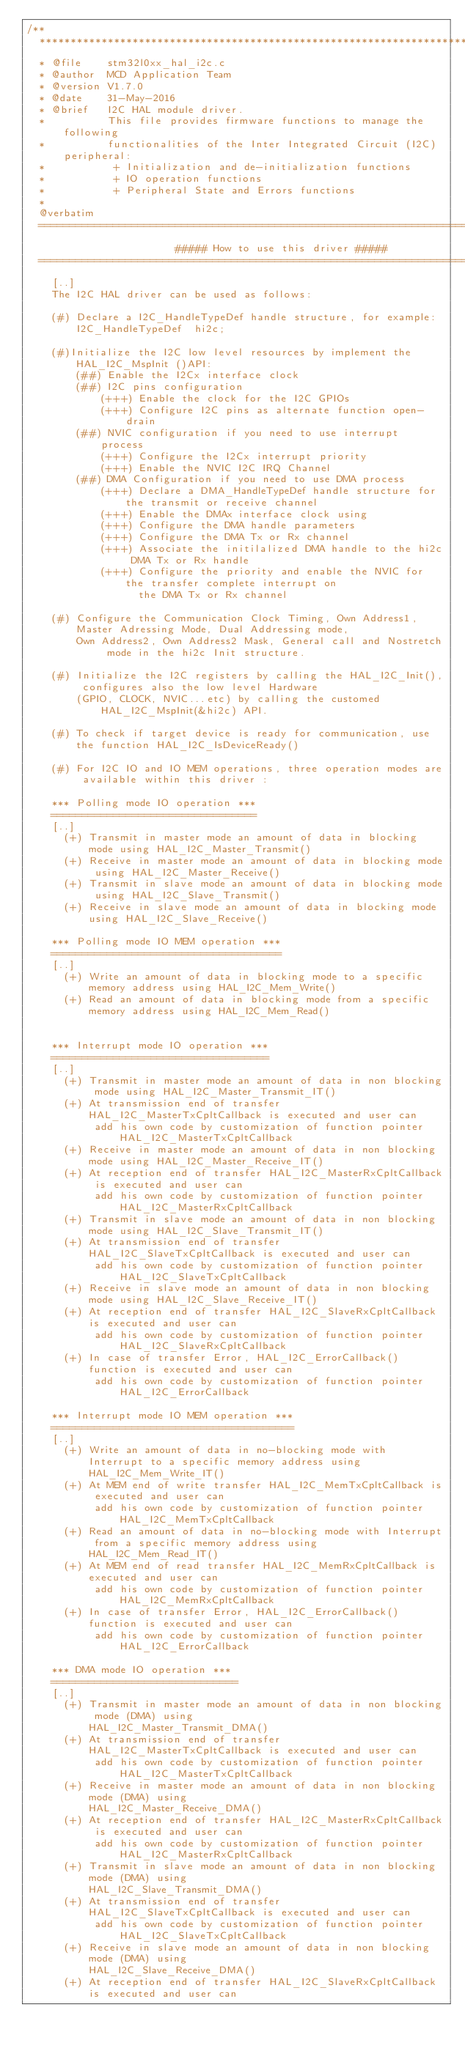<code> <loc_0><loc_0><loc_500><loc_500><_C_>/**
  ******************************************************************************
  * @file    stm32l0xx_hal_i2c.c
  * @author  MCD Application Team
  * @version V1.7.0
  * @date    31-May-2016
  * @brief   I2C HAL module driver.
  *          This file provides firmware functions to manage the following 
  *          functionalities of the Inter Integrated Circuit (I2C) peripheral:
  *           + Initialization and de-initialization functions
  *           + IO operation functions
  *           + Peripheral State and Errors functions
  *         
  @verbatim
  ==============================================================================
                        ##### How to use this driver #####
  ==============================================================================
    [..]
    The I2C HAL driver can be used as follows:
    
    (#) Declare a I2C_HandleTypeDef handle structure, for example:
        I2C_HandleTypeDef  hi2c; 

    (#)Initialize the I2C low level resources by implement the HAL_I2C_MspInit ()API:
        (##) Enable the I2Cx interface clock
        (##) I2C pins configuration
            (+++) Enable the clock for the I2C GPIOs
            (+++) Configure I2C pins as alternate function open-drain
        (##) NVIC configuration if you need to use interrupt process
            (+++) Configure the I2Cx interrupt priority
            (+++) Enable the NVIC I2C IRQ Channel
        (##) DMA Configuration if you need to use DMA process
            (+++) Declare a DMA_HandleTypeDef handle structure for the transmit or receive channel
            (+++) Enable the DMAx interface clock using
            (+++) Configure the DMA handle parameters
            (+++) Configure the DMA Tx or Rx channel
            (+++) Associate the initilalized DMA handle to the hi2c DMA Tx or Rx handle
            (+++) Configure the priority and enable the NVIC for the transfer complete interrupt on 
                  the DMA Tx or Rx channel

    (#) Configure the Communication Clock Timing, Own Address1, Master Adressing Mode, Dual Addressing mode,
        Own Address2, Own Address2 Mask, General call and Nostretch mode in the hi2c Init structure.

    (#) Initialize the I2C registers by calling the HAL_I2C_Init(), configures also the low level Hardware 
        (GPIO, CLOCK, NVIC...etc) by calling the customed HAL_I2C_MspInit(&hi2c) API.

    (#) To check if target device is ready for communication, use the function HAL_I2C_IsDeviceReady()

    (#) For I2C IO and IO MEM operations, three operation modes are available within this driver :

    *** Polling mode IO operation ***
    =================================
    [..]
      (+) Transmit in master mode an amount of data in blocking mode using HAL_I2C_Master_Transmit()
      (+) Receive in master mode an amount of data in blocking mode using HAL_I2C_Master_Receive()
      (+) Transmit in slave mode an amount of data in blocking mode using HAL_I2C_Slave_Transmit()
      (+) Receive in slave mode an amount of data in blocking mode using HAL_I2C_Slave_Receive()

    *** Polling mode IO MEM operation ***
    =====================================
    [..]
      (+) Write an amount of data in blocking mode to a specific memory address using HAL_I2C_Mem_Write()
      (+) Read an amount of data in blocking mode from a specific memory address using HAL_I2C_Mem_Read()


    *** Interrupt mode IO operation ***
    ===================================
    [..]
      (+) Transmit in master mode an amount of data in non blocking mode using HAL_I2C_Master_Transmit_IT()
      (+) At transmission end of transfer HAL_I2C_MasterTxCpltCallback is executed and user can
           add his own code by customization of function pointer HAL_I2C_MasterTxCpltCallback
      (+) Receive in master mode an amount of data in non blocking mode using HAL_I2C_Master_Receive_IT()
      (+) At reception end of transfer HAL_I2C_MasterRxCpltCallback is executed and user can
           add his own code by customization of function pointer HAL_I2C_MasterRxCpltCallback
      (+) Transmit in slave mode an amount of data in non blocking mode using HAL_I2C_Slave_Transmit_IT()
      (+) At transmission end of transfer HAL_I2C_SlaveTxCpltCallback is executed and user can
           add his own code by customization of function pointer HAL_I2C_SlaveTxCpltCallback
      (+) Receive in slave mode an amount of data in non blocking mode using HAL_I2C_Slave_Receive_IT()
      (+) At reception end of transfer HAL_I2C_SlaveRxCpltCallback is executed and user can
           add his own code by customization of function pointer HAL_I2C_SlaveRxCpltCallback
      (+) In case of transfer Error, HAL_I2C_ErrorCallback() function is executed and user can
           add his own code by customization of function pointer HAL_I2C_ErrorCallback

    *** Interrupt mode IO MEM operation ***
    =======================================
    [..]
      (+) Write an amount of data in no-blocking mode with Interrupt to a specific memory address using
          HAL_I2C_Mem_Write_IT()
      (+) At MEM end of write transfer HAL_I2C_MemTxCpltCallback is executed and user can
           add his own code by customization of function pointer HAL_I2C_MemTxCpltCallback
      (+) Read an amount of data in no-blocking mode with Interrupt from a specific memory address using
          HAL_I2C_Mem_Read_IT()
      (+) At MEM end of read transfer HAL_I2C_MemRxCpltCallback is executed and user can
           add his own code by customization of function pointer HAL_I2C_MemRxCpltCallback
      (+) In case of transfer Error, HAL_I2C_ErrorCallback() function is executed and user can
           add his own code by customization of function pointer HAL_I2C_ErrorCallback

    *** DMA mode IO operation ***
    ==============================
    [..]
      (+) Transmit in master mode an amount of data in non blocking mode (DMA) using
          HAL_I2C_Master_Transmit_DMA()
      (+) At transmission end of transfer HAL_I2C_MasterTxCpltCallback is executed and user can
           add his own code by customization of function pointer HAL_I2C_MasterTxCpltCallback
      (+) Receive in master mode an amount of data in non blocking mode (DMA) using
          HAL_I2C_Master_Receive_DMA()
      (+) At reception end of transfer HAL_I2C_MasterRxCpltCallback is executed and user can
           add his own code by customization of function pointer HAL_I2C_MasterRxCpltCallback
      (+) Transmit in slave mode an amount of data in non blocking mode (DMA) using
          HAL_I2C_Slave_Transmit_DMA()
      (+) At transmission end of transfer HAL_I2C_SlaveTxCpltCallback is executed and user can
           add his own code by customization of function pointer HAL_I2C_SlaveTxCpltCallback
      (+) Receive in slave mode an amount of data in non blocking mode (DMA) using
          HAL_I2C_Slave_Receive_DMA()
      (+) At reception end of transfer HAL_I2C_SlaveRxCpltCallback is executed and user can</code> 